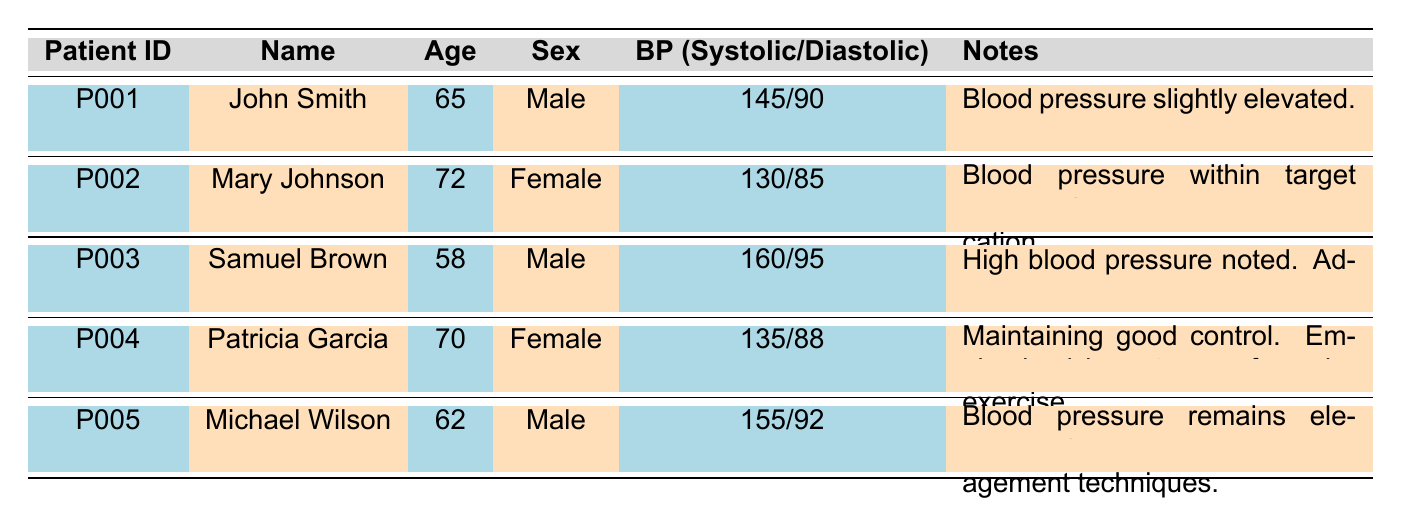What is the blood pressure reading of Samuel Brown? According to the table, Samuel Brown's blood pressure reading is listed as 160/95, which refers to his systolic and diastolic values.
Answer: 160/95 How many patients have blood pressure readings above 140/90? Evaluating the table, the patients with readings above 140/90 are John Smith (145/90), Samuel Brown (160/95), and Michael Wilson (155/92). That totals three patients.
Answer: 3 Is Mary Johnson's blood pressure reading within the target range? The table states that Mary Johnson's blood pressure is 130/85, and notes indicate it is within the target range. Hence, the answer is yes.
Answer: Yes What is the average systolic blood pressure of the patients listed? The systolic values are 145 (John Smith) + 130 (Mary Johnson) + 160 (Samuel Brown) + 135 (Patricia Garcia) + 155 (Michael Wilson) = 725. Dividing by the total number of patients (5) gives an average of 725/5 = 145.
Answer: 145 Do any female patients have high blood pressure noted? Reviewing the table, Patricia Garcia's reading of 135/88 is not classified as high, and Mary Johnson has a reading of 130/85. Therefore, no female patients have high blood pressure noted in the records provided.
Answer: No Who has the highest systolic reading among the patients? Looking at the systolic readings, Samuel Brown has the highest value at 160, while John Smith has 145, Patricia Garcia has 135, and Michael Wilson has 155. Therefore, Samuel Brown is the one with the highest systolic reading.
Answer: Samuel Brown What specific advice was given to Michael Wilson during his check-up? The table notes that for Michael Wilson, it was suggested to use stress management techniques due to his elevated blood pressure reading.
Answer: Suggested stress management techniques What is the diastolic pressure of John Smith? According to the table, John Smith's diastolic pressure reading is 90, as indicated in the blood pressure values provided.
Answer: 90 